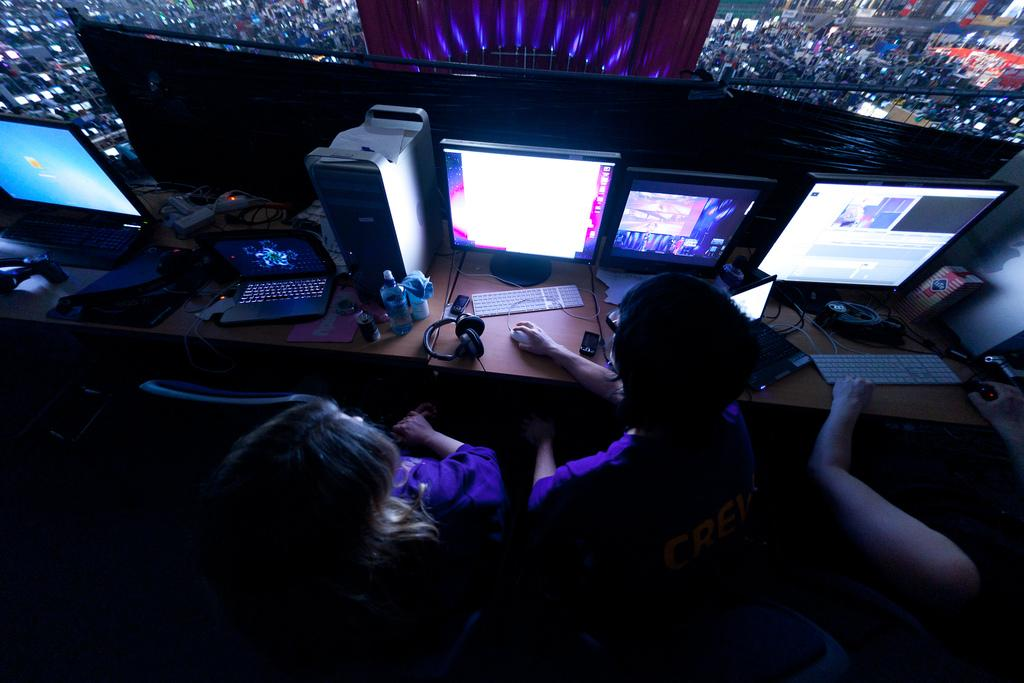What are the people in the image doing? The people in the image are sitting on chairs and holding a mouse. What can be seen on the table in the image? Monitors, a laptop, bottles, a keyboard, a CPU, and wires are present on the table. What might the people be using the mouse for? The people might be using the mouse to interact with the computer, as there are monitors, a laptop, and a keyboard on the table. How does the duck in the image get the attention of the people? There is no duck present in the image; it only features people sitting on chairs and various computer-related items on the table. 